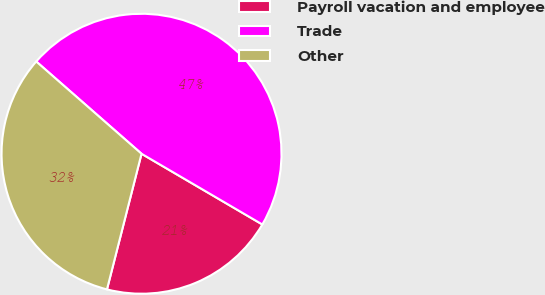Convert chart. <chart><loc_0><loc_0><loc_500><loc_500><pie_chart><fcel>Payroll vacation and employee<fcel>Trade<fcel>Other<nl><fcel>20.54%<fcel>46.98%<fcel>32.48%<nl></chart> 